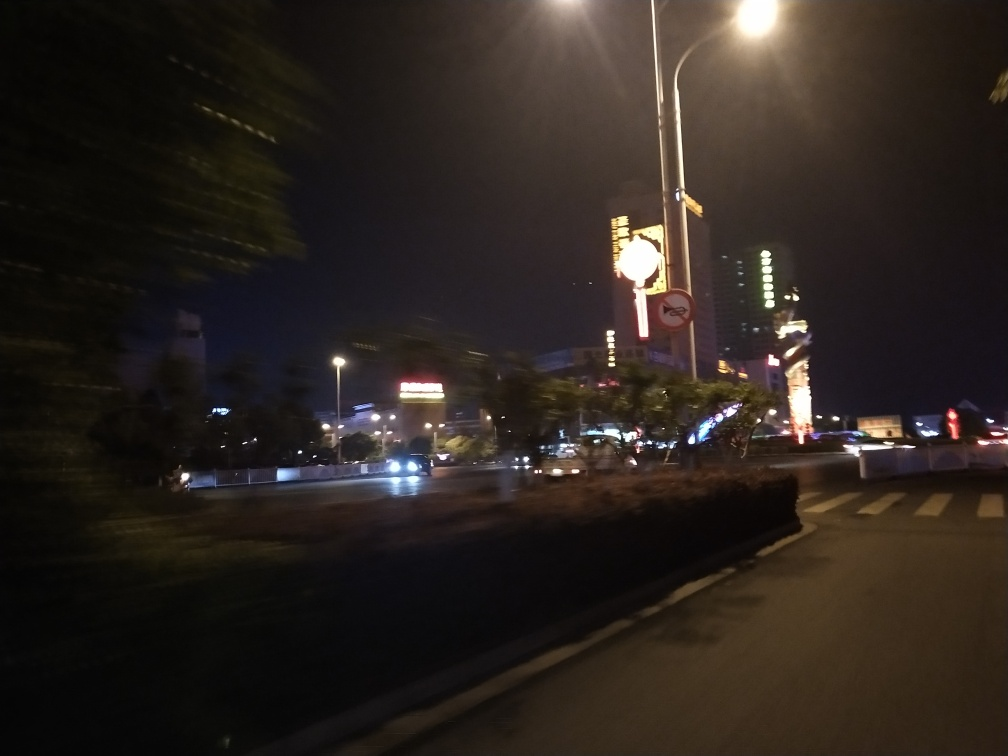What time of day does this photo seem to have been taken? The photo appears to have been taken at nighttime. This is indicated by the urban lighting, illuminated billboards, and the dark sky, which together suggest that the sun has set. 